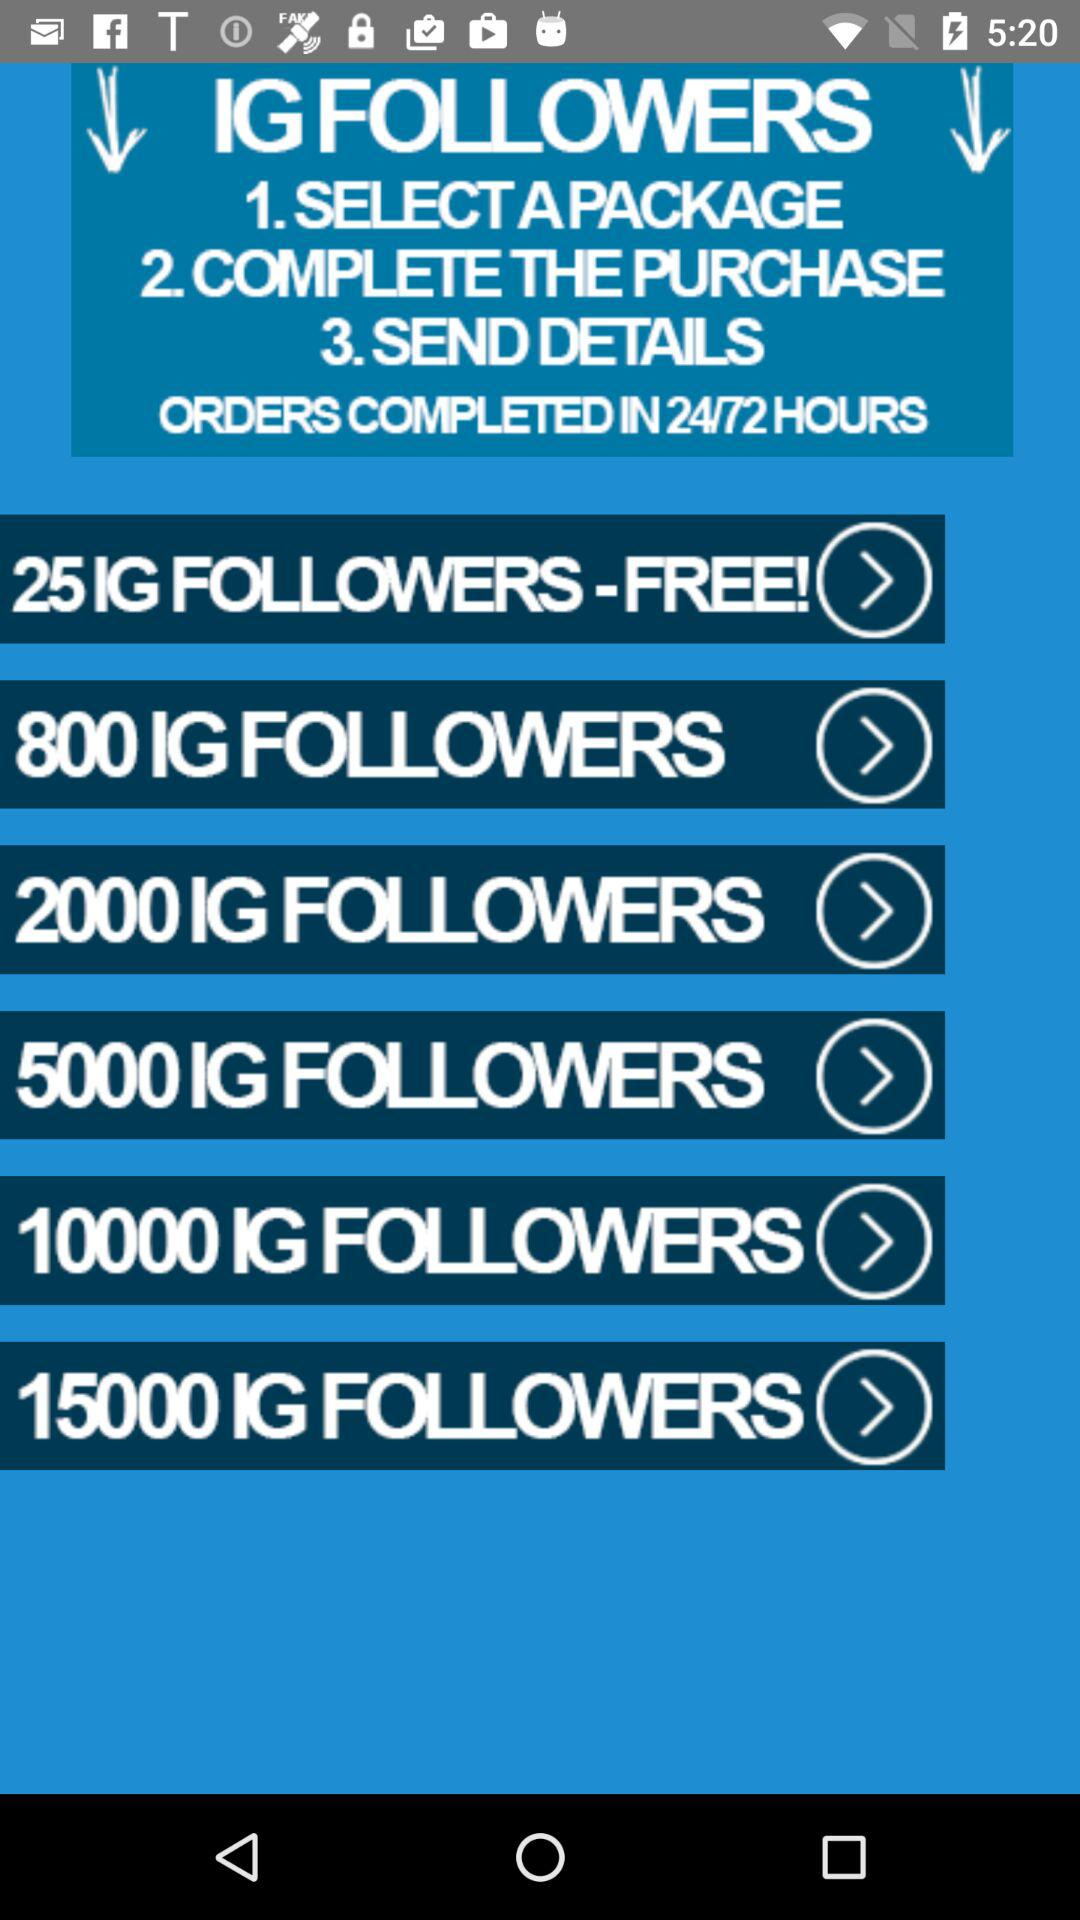How many more IG followers does the 10000 IG Followers package offer than the 2000 IG Followers package?
Answer the question using a single word or phrase. 8000 